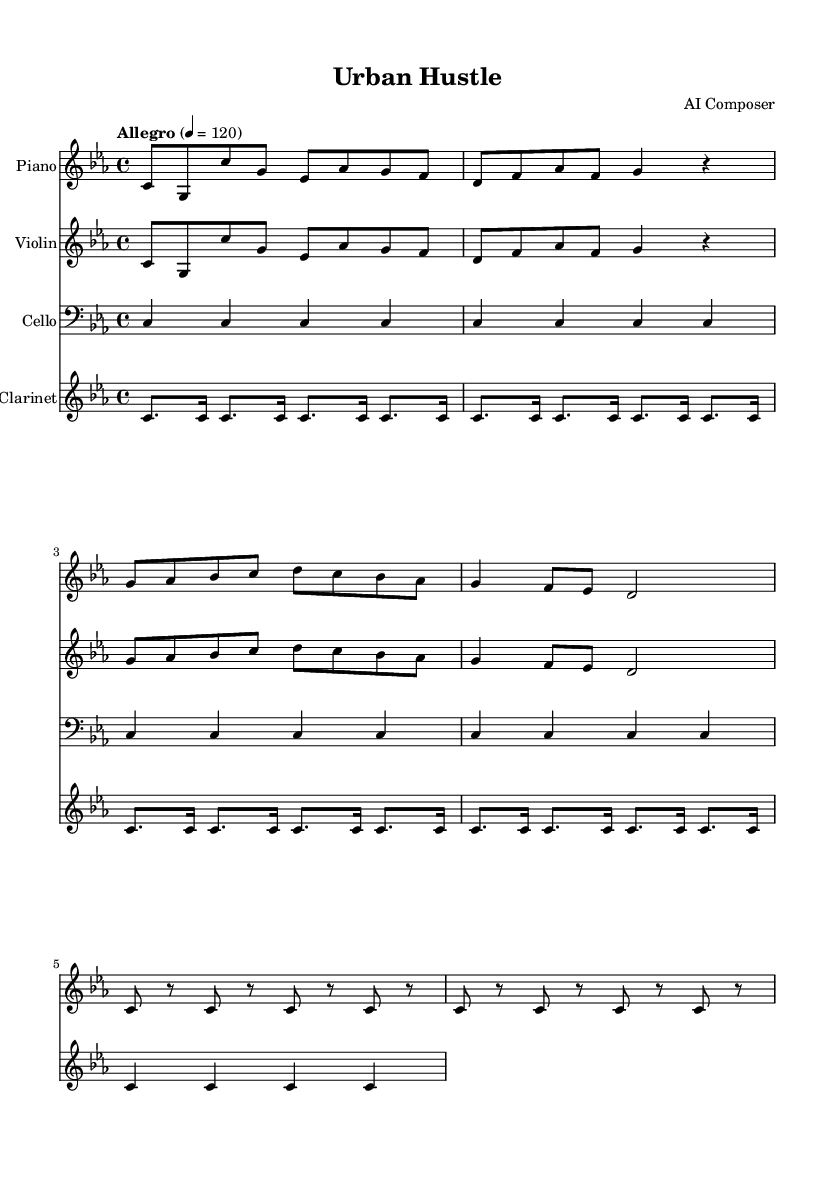What is the key signature of this music? The key signature is indicated at the beginning of the piece, and it shows 3 flats, which corresponds to C minor.
Answer: C minor What is the time signature of this music? The time signature appears at the start, displaying a 4/4 text indicating four beats per measure with a quarter note getting one beat.
Answer: 4/4 What is the tempo marking for this piece? The tempo marking specifies a speed and is typically located at the beginning; here it is marked "Allegro" with a metronome marking of 120 beats per minute.
Answer: Allegro, 120 How many measures are there in the piano part? The total number of measures can be counted directly in the piano section, and there are eight measures present.
Answer: 8 What is the highest pitch played by the clarinet in this piece? By analyzing the clarinet part, the highest pitch notated is a high C, which is the first note of the phrase.
Answer: C What is the instrument that plays in the bass clef? The bass clef signifies lower pitches and is used for the cello, which is notated to use the bass clef throughout the section.
Answer: Cello What is the rhythmic value of the first note in the piano part? The first note is an eighth note, as seen by its notation with a filled note head and a stem pointing upward, indicating it lasts for half a beat.
Answer: Eighth note 